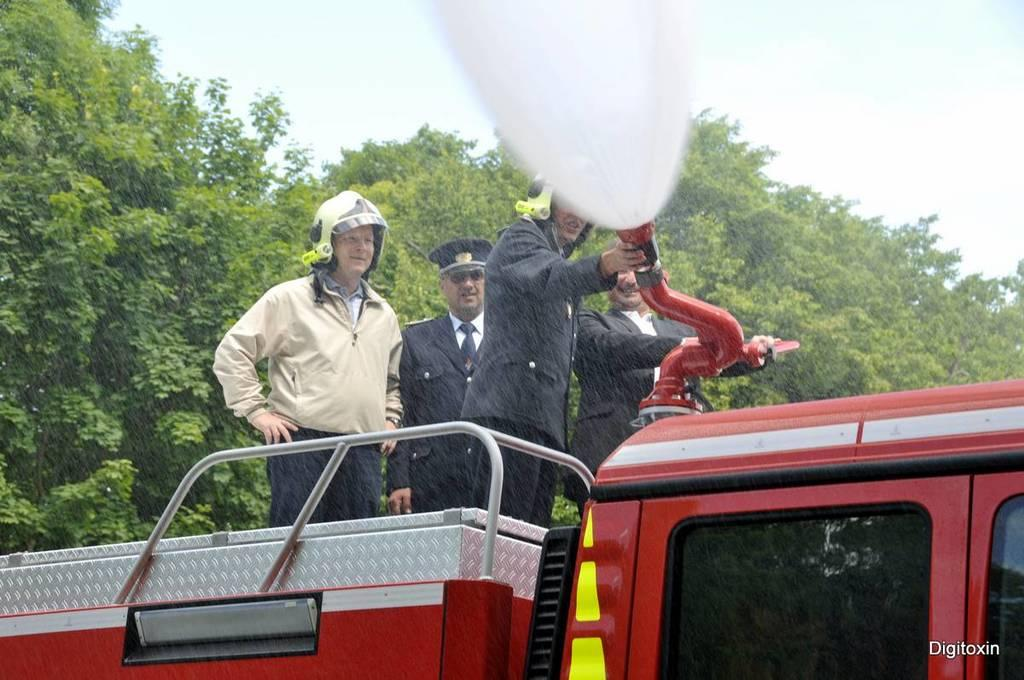What are the people doing in the image? The people are standing on a vehicle. What are the people holding on the right side? People are holding a pipe on the right side. What can be seen in the background of the image? There is water visible in the image, as well as trees. What is visible in the sky? Clouds are visible in the sky. How many babies are visible in the image? There are no babies present in the image. What type of drug can be seen in the hands of the people in the image? There is no drug visible in the image; people are holding a pipe. 